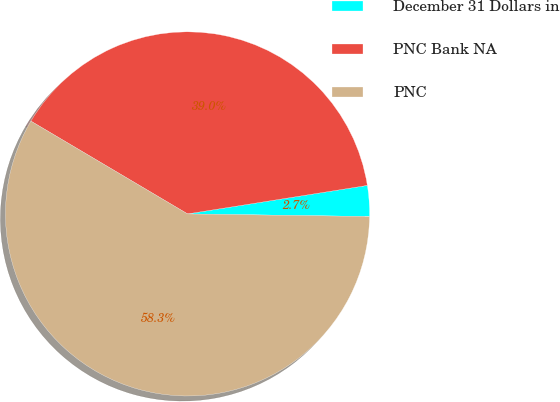Convert chart. <chart><loc_0><loc_0><loc_500><loc_500><pie_chart><fcel>December 31 Dollars in<fcel>PNC Bank NA<fcel>PNC<nl><fcel>2.73%<fcel>38.99%<fcel>58.28%<nl></chart> 